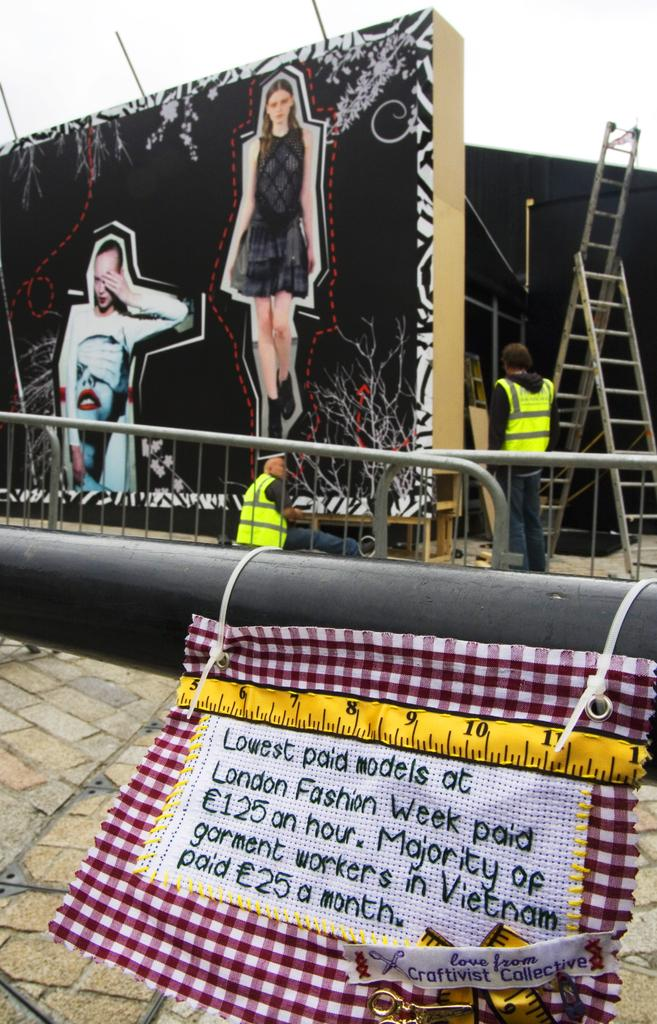What is hanging on the rod in the image? There is cloth hanging on a rod in the image. What can be seen on the cloth? Text is visible on the cloth. What can be observed in the background of the image? There are people, pictures of women on a board, a ladder, and the sky visible in the background of the image. Can you tell me how many hens are sitting on the ladder in the image? There are no hens present in the image; the only animals mentioned are women in the pictures on the board. What type of linen is used to make the cloth in the image? The type of linen used to make the cloth is not mentioned in the image, so it cannot be determined. 